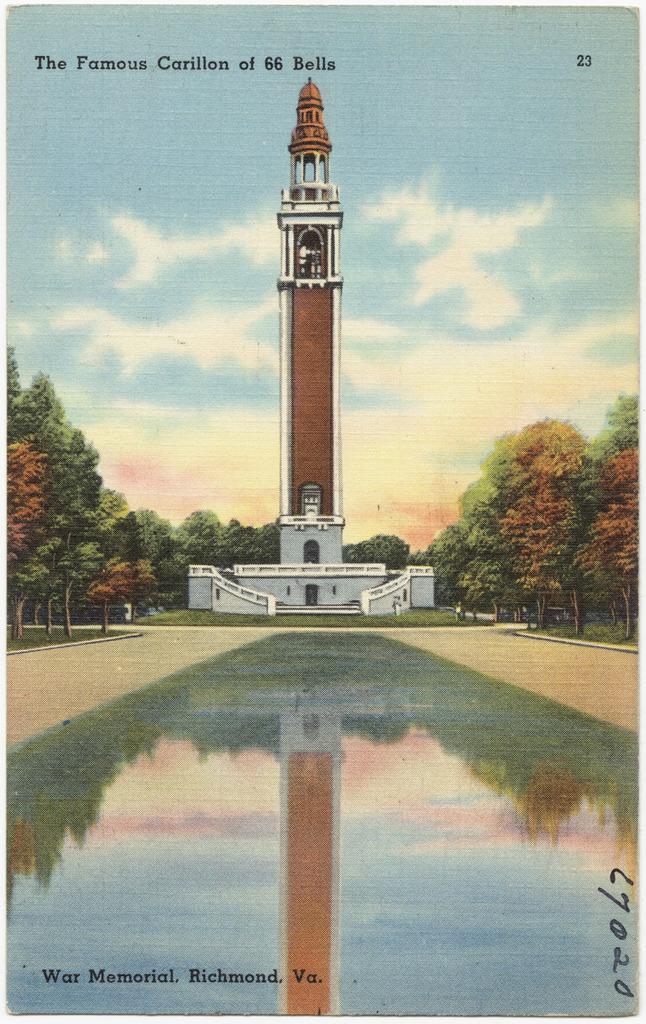Could you give a brief overview of what you see in this image? This image is a depiction. In this image we can see a tower building, trees, grass, water and also the path. We can also see the sky with the clouds. Image also consists of the text and also numbers. 